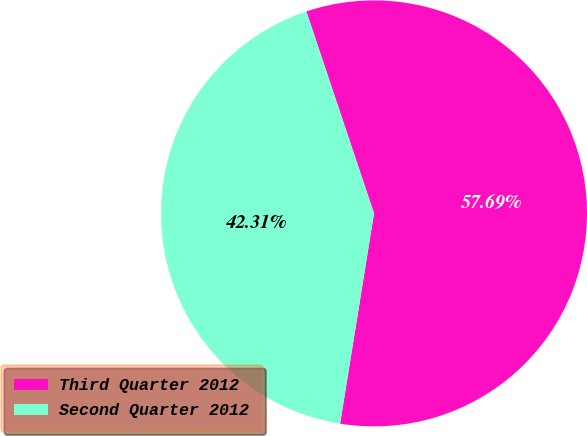Convert chart to OTSL. <chart><loc_0><loc_0><loc_500><loc_500><pie_chart><fcel>Third Quarter 2012<fcel>Second Quarter 2012<nl><fcel>57.69%<fcel>42.31%<nl></chart> 